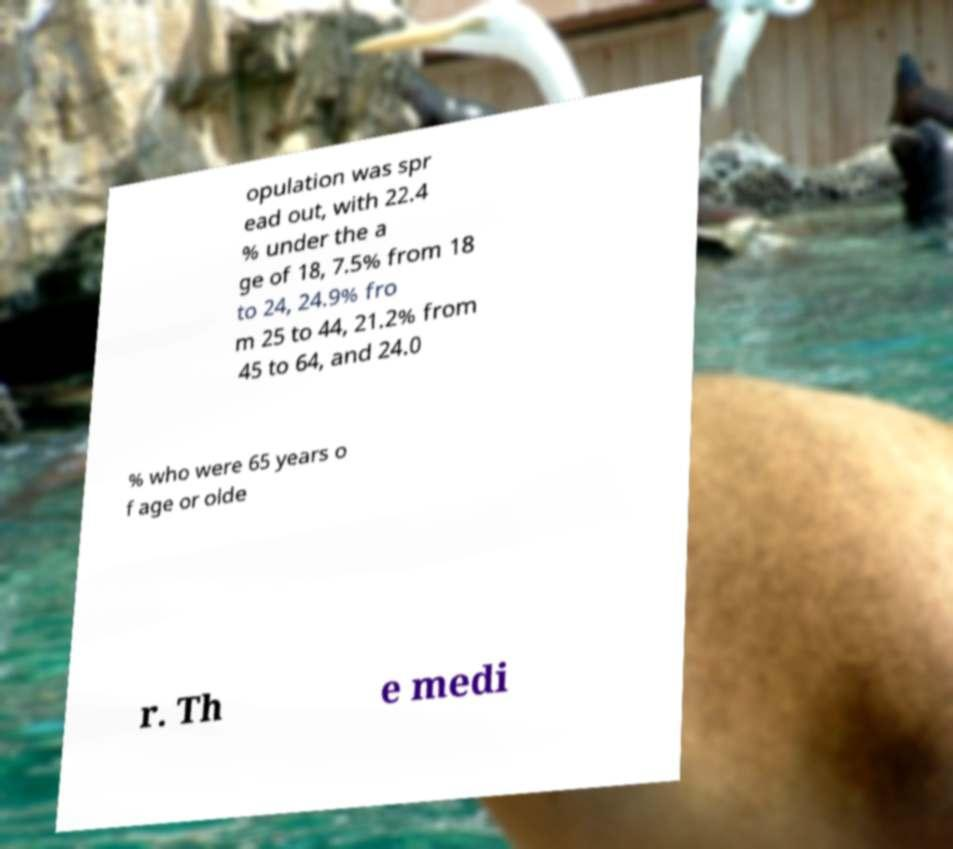What messages or text are displayed in this image? I need them in a readable, typed format. opulation was spr ead out, with 22.4 % under the a ge of 18, 7.5% from 18 to 24, 24.9% fro m 25 to 44, 21.2% from 45 to 64, and 24.0 % who were 65 years o f age or olde r. Th e medi 